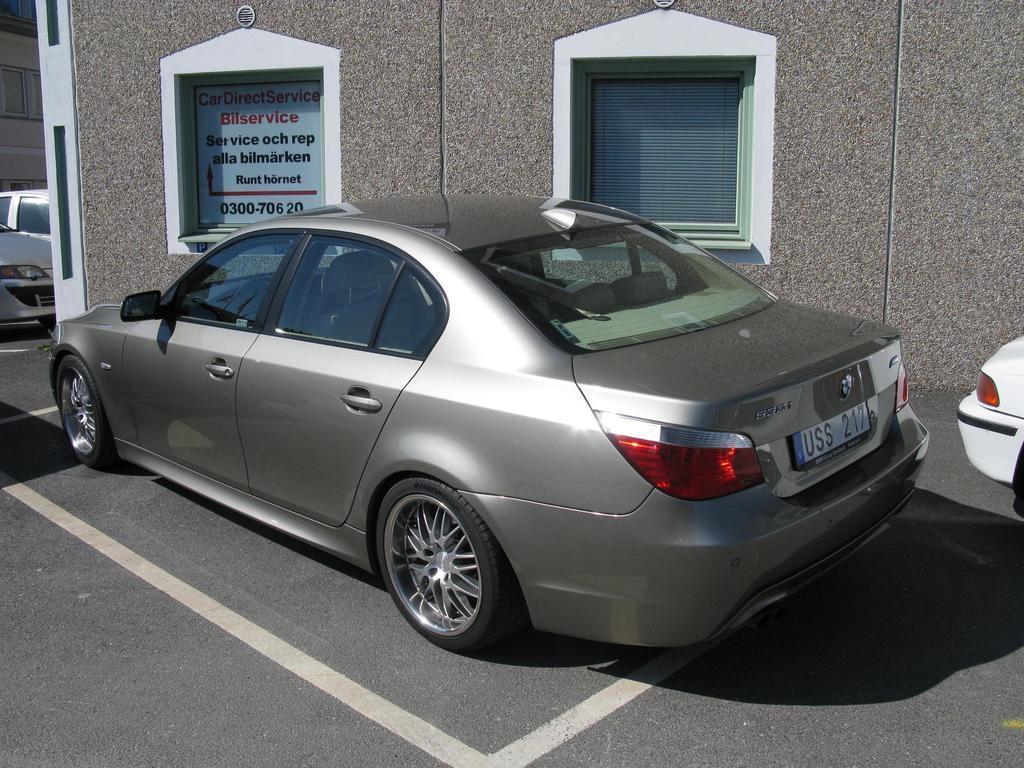Could you give a brief overview of what you see in this image? In this image we can see cars on the road. There are buildings, text written on an object on the wall, windows and window blind. 